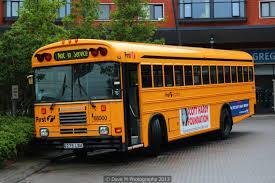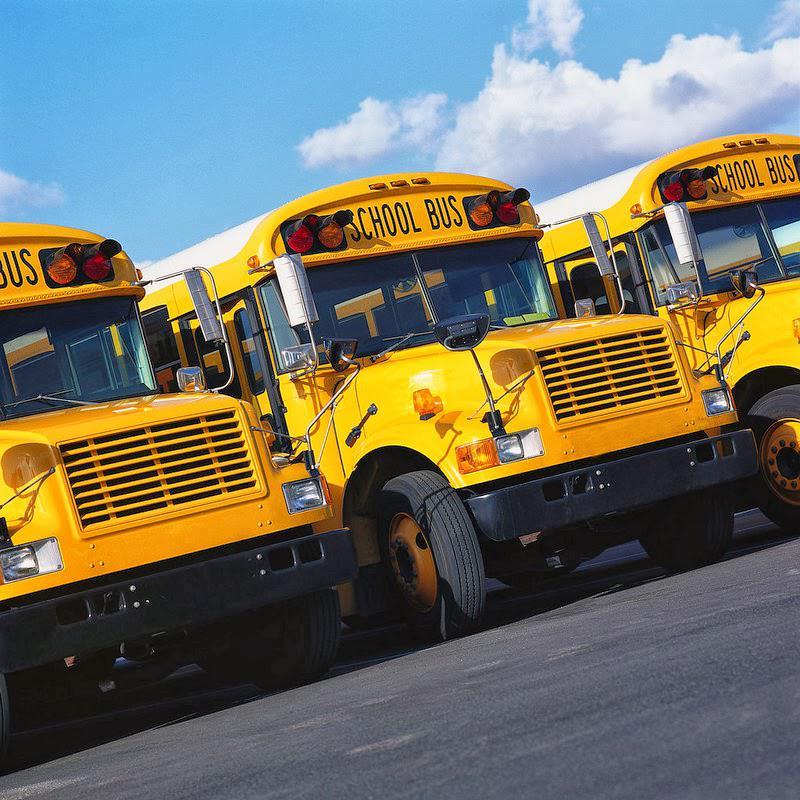The first image is the image on the left, the second image is the image on the right. Evaluate the accuracy of this statement regarding the images: "One image in the pair shows a single school bus while the other shows at least three.". Is it true? Answer yes or no. Yes. The first image is the image on the left, the second image is the image on the right. Examine the images to the left and right. Is the description "One image shows the rear of a bright yellow school bus, including its emergency door and sets of red and amber lights on the top." accurate? Answer yes or no. No. 